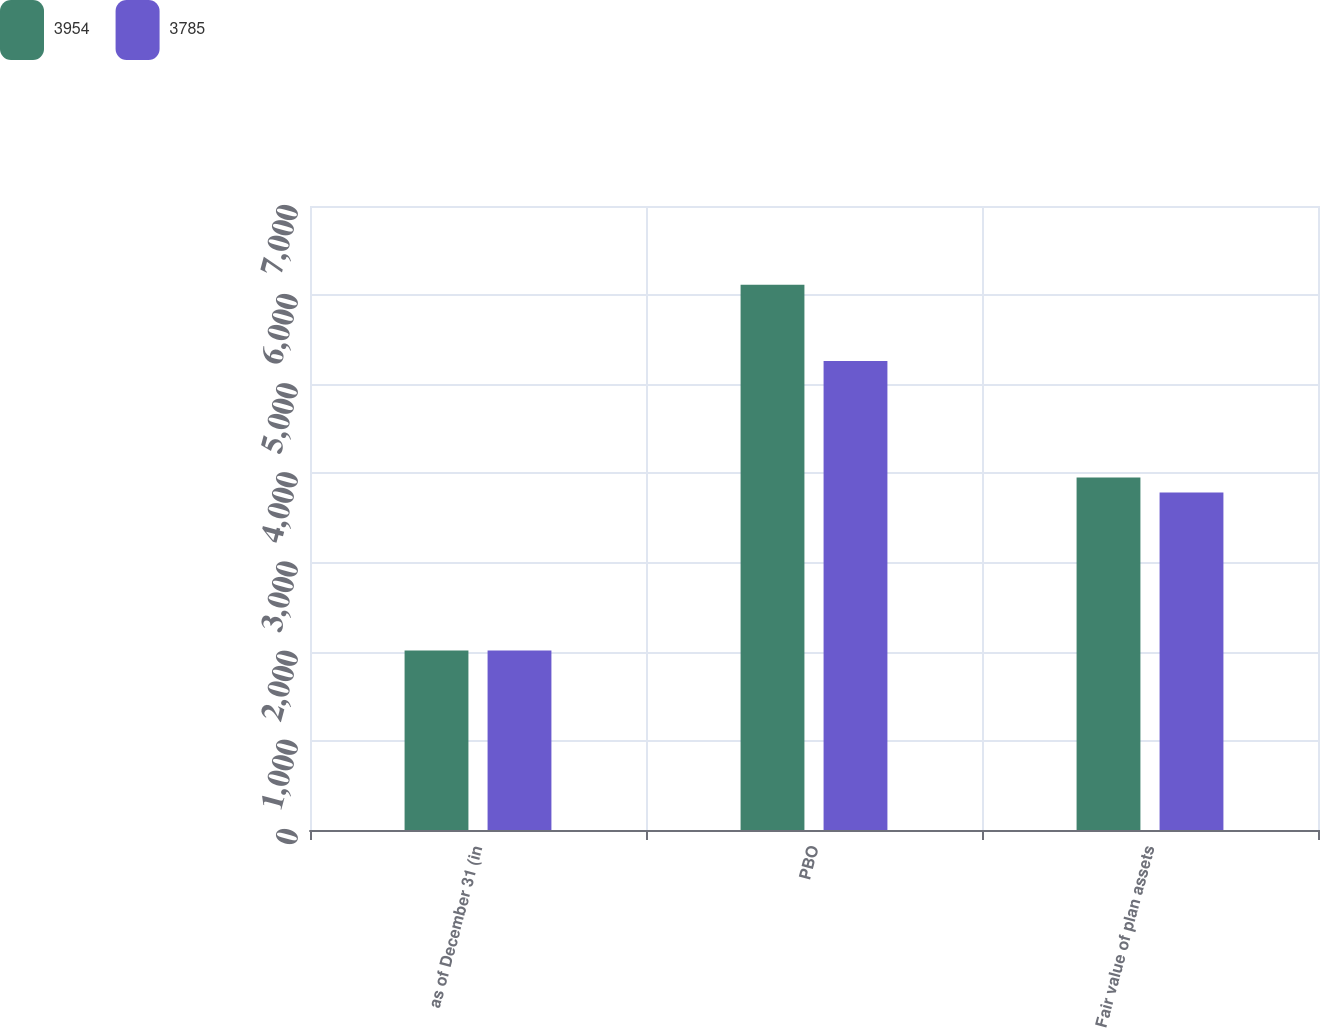Convert chart. <chart><loc_0><loc_0><loc_500><loc_500><stacked_bar_chart><ecel><fcel>as of December 31 (in<fcel>PBO<fcel>Fair value of plan assets<nl><fcel>3954<fcel>2014<fcel>6117<fcel>3954<nl><fcel>3785<fcel>2013<fcel>5260<fcel>3785<nl></chart> 